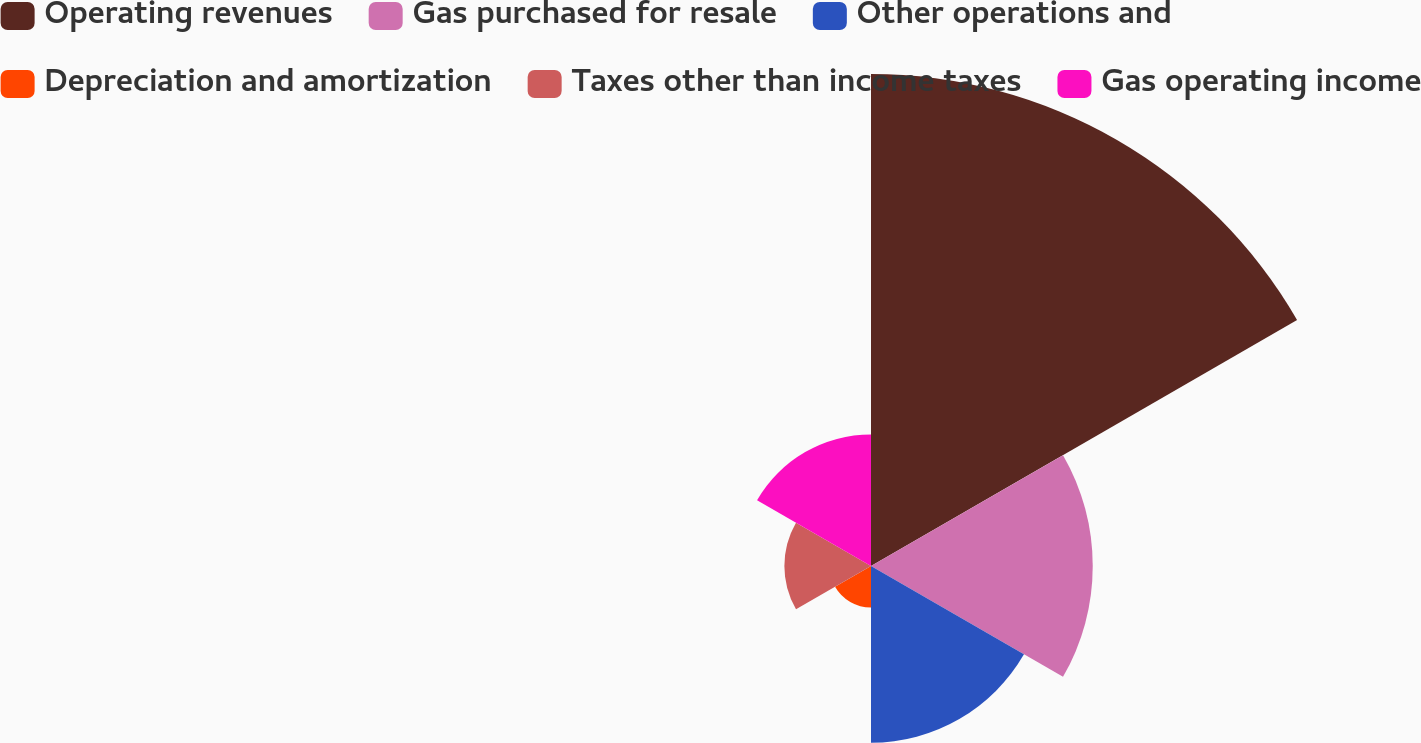Convert chart. <chart><loc_0><loc_0><loc_500><loc_500><pie_chart><fcel>Operating revenues<fcel>Gas purchased for resale<fcel>Other operations and<fcel>Depreciation and amortization<fcel>Taxes other than income taxes<fcel>Gas operating income<nl><fcel>42.78%<fcel>19.28%<fcel>15.36%<fcel>3.61%<fcel>7.53%<fcel>11.44%<nl></chart> 